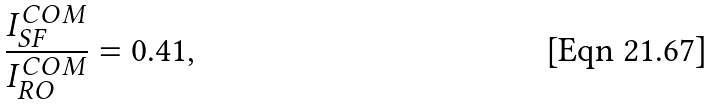<formula> <loc_0><loc_0><loc_500><loc_500>\frac { I _ { S F } ^ { C O M } } { I _ { R O } ^ { C O M } } = 0 . 4 1 ,</formula> 